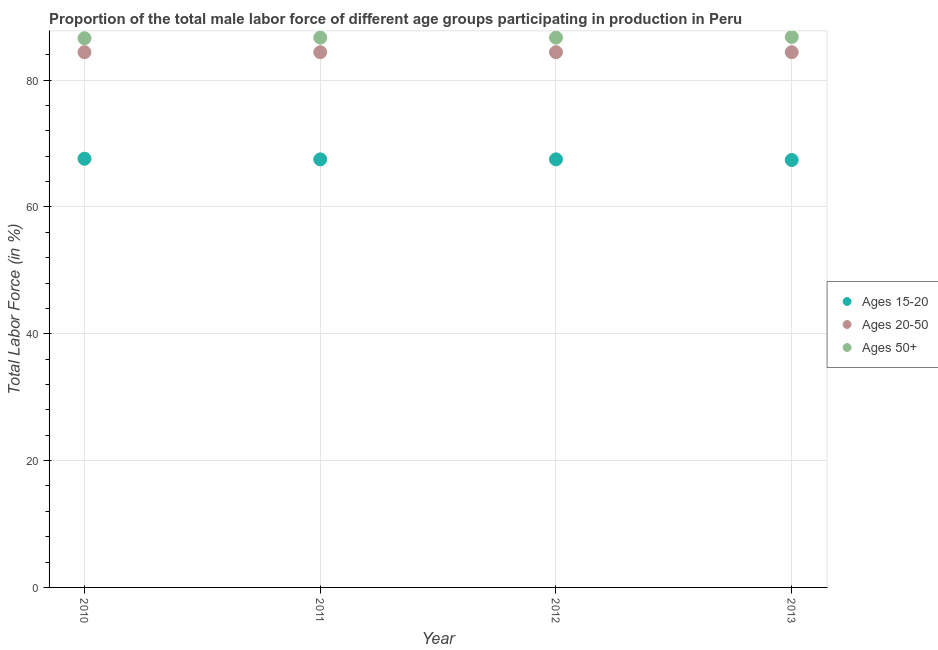Is the number of dotlines equal to the number of legend labels?
Keep it short and to the point. Yes. What is the percentage of male labor force above age 50 in 2012?
Your response must be concise. 86.7. Across all years, what is the maximum percentage of male labor force within the age group 20-50?
Provide a short and direct response. 84.4. Across all years, what is the minimum percentage of male labor force within the age group 20-50?
Keep it short and to the point. 84.4. In which year was the percentage of male labor force within the age group 20-50 minimum?
Give a very brief answer. 2010. What is the total percentage of male labor force within the age group 20-50 in the graph?
Your response must be concise. 337.6. What is the difference between the percentage of male labor force within the age group 20-50 in 2010 and that in 2012?
Offer a terse response. 0. What is the difference between the percentage of male labor force above age 50 in 2011 and the percentage of male labor force within the age group 15-20 in 2012?
Your response must be concise. 19.2. What is the average percentage of male labor force within the age group 15-20 per year?
Your response must be concise. 67.5. In the year 2011, what is the difference between the percentage of male labor force within the age group 15-20 and percentage of male labor force within the age group 20-50?
Your answer should be very brief. -16.9. What is the ratio of the percentage of male labor force above age 50 in 2011 to that in 2013?
Offer a terse response. 1. What is the difference between the highest and the second highest percentage of male labor force within the age group 15-20?
Make the answer very short. 0.1. What is the difference between the highest and the lowest percentage of male labor force above age 50?
Make the answer very short. 0.2. Is it the case that in every year, the sum of the percentage of male labor force within the age group 15-20 and percentage of male labor force within the age group 20-50 is greater than the percentage of male labor force above age 50?
Give a very brief answer. Yes. Does the percentage of male labor force within the age group 15-20 monotonically increase over the years?
Your answer should be very brief. No. Is the percentage of male labor force within the age group 15-20 strictly greater than the percentage of male labor force above age 50 over the years?
Provide a short and direct response. No. How many dotlines are there?
Offer a terse response. 3. How many years are there in the graph?
Keep it short and to the point. 4. Are the values on the major ticks of Y-axis written in scientific E-notation?
Ensure brevity in your answer.  No. Does the graph contain any zero values?
Ensure brevity in your answer.  No. How are the legend labels stacked?
Your response must be concise. Vertical. What is the title of the graph?
Your response must be concise. Proportion of the total male labor force of different age groups participating in production in Peru. Does "Slovak Republic" appear as one of the legend labels in the graph?
Give a very brief answer. No. What is the label or title of the Y-axis?
Give a very brief answer. Total Labor Force (in %). What is the Total Labor Force (in %) of Ages 15-20 in 2010?
Your answer should be very brief. 67.6. What is the Total Labor Force (in %) in Ages 20-50 in 2010?
Ensure brevity in your answer.  84.4. What is the Total Labor Force (in %) in Ages 50+ in 2010?
Your response must be concise. 86.6. What is the Total Labor Force (in %) of Ages 15-20 in 2011?
Offer a terse response. 67.5. What is the Total Labor Force (in %) in Ages 20-50 in 2011?
Ensure brevity in your answer.  84.4. What is the Total Labor Force (in %) in Ages 50+ in 2011?
Offer a very short reply. 86.7. What is the Total Labor Force (in %) in Ages 15-20 in 2012?
Give a very brief answer. 67.5. What is the Total Labor Force (in %) in Ages 20-50 in 2012?
Provide a succinct answer. 84.4. What is the Total Labor Force (in %) of Ages 50+ in 2012?
Make the answer very short. 86.7. What is the Total Labor Force (in %) of Ages 15-20 in 2013?
Ensure brevity in your answer.  67.4. What is the Total Labor Force (in %) of Ages 20-50 in 2013?
Give a very brief answer. 84.4. What is the Total Labor Force (in %) of Ages 50+ in 2013?
Give a very brief answer. 86.8. Across all years, what is the maximum Total Labor Force (in %) of Ages 15-20?
Offer a very short reply. 67.6. Across all years, what is the maximum Total Labor Force (in %) in Ages 20-50?
Offer a very short reply. 84.4. Across all years, what is the maximum Total Labor Force (in %) in Ages 50+?
Keep it short and to the point. 86.8. Across all years, what is the minimum Total Labor Force (in %) in Ages 15-20?
Offer a terse response. 67.4. Across all years, what is the minimum Total Labor Force (in %) in Ages 20-50?
Provide a short and direct response. 84.4. Across all years, what is the minimum Total Labor Force (in %) in Ages 50+?
Your answer should be compact. 86.6. What is the total Total Labor Force (in %) in Ages 15-20 in the graph?
Offer a very short reply. 270. What is the total Total Labor Force (in %) of Ages 20-50 in the graph?
Ensure brevity in your answer.  337.6. What is the total Total Labor Force (in %) in Ages 50+ in the graph?
Provide a short and direct response. 346.8. What is the difference between the Total Labor Force (in %) in Ages 15-20 in 2010 and that in 2011?
Ensure brevity in your answer.  0.1. What is the difference between the Total Labor Force (in %) in Ages 50+ in 2010 and that in 2011?
Offer a terse response. -0.1. What is the difference between the Total Labor Force (in %) of Ages 15-20 in 2010 and that in 2012?
Provide a succinct answer. 0.1. What is the difference between the Total Labor Force (in %) of Ages 20-50 in 2010 and that in 2012?
Your response must be concise. 0. What is the difference between the Total Labor Force (in %) in Ages 15-20 in 2010 and that in 2013?
Provide a short and direct response. 0.2. What is the difference between the Total Labor Force (in %) in Ages 20-50 in 2010 and that in 2013?
Your answer should be very brief. 0. What is the difference between the Total Labor Force (in %) in Ages 15-20 in 2011 and that in 2012?
Keep it short and to the point. 0. What is the difference between the Total Labor Force (in %) in Ages 20-50 in 2011 and that in 2013?
Your response must be concise. 0. What is the difference between the Total Labor Force (in %) of Ages 50+ in 2011 and that in 2013?
Make the answer very short. -0.1. What is the difference between the Total Labor Force (in %) in Ages 15-20 in 2010 and the Total Labor Force (in %) in Ages 20-50 in 2011?
Offer a terse response. -16.8. What is the difference between the Total Labor Force (in %) of Ages 15-20 in 2010 and the Total Labor Force (in %) of Ages 50+ in 2011?
Your answer should be very brief. -19.1. What is the difference between the Total Labor Force (in %) of Ages 20-50 in 2010 and the Total Labor Force (in %) of Ages 50+ in 2011?
Keep it short and to the point. -2.3. What is the difference between the Total Labor Force (in %) of Ages 15-20 in 2010 and the Total Labor Force (in %) of Ages 20-50 in 2012?
Offer a very short reply. -16.8. What is the difference between the Total Labor Force (in %) of Ages 15-20 in 2010 and the Total Labor Force (in %) of Ages 50+ in 2012?
Provide a short and direct response. -19.1. What is the difference between the Total Labor Force (in %) of Ages 20-50 in 2010 and the Total Labor Force (in %) of Ages 50+ in 2012?
Offer a terse response. -2.3. What is the difference between the Total Labor Force (in %) of Ages 15-20 in 2010 and the Total Labor Force (in %) of Ages 20-50 in 2013?
Offer a terse response. -16.8. What is the difference between the Total Labor Force (in %) in Ages 15-20 in 2010 and the Total Labor Force (in %) in Ages 50+ in 2013?
Your response must be concise. -19.2. What is the difference between the Total Labor Force (in %) in Ages 15-20 in 2011 and the Total Labor Force (in %) in Ages 20-50 in 2012?
Offer a terse response. -16.9. What is the difference between the Total Labor Force (in %) of Ages 15-20 in 2011 and the Total Labor Force (in %) of Ages 50+ in 2012?
Offer a terse response. -19.2. What is the difference between the Total Labor Force (in %) of Ages 20-50 in 2011 and the Total Labor Force (in %) of Ages 50+ in 2012?
Your answer should be very brief. -2.3. What is the difference between the Total Labor Force (in %) in Ages 15-20 in 2011 and the Total Labor Force (in %) in Ages 20-50 in 2013?
Give a very brief answer. -16.9. What is the difference between the Total Labor Force (in %) of Ages 15-20 in 2011 and the Total Labor Force (in %) of Ages 50+ in 2013?
Keep it short and to the point. -19.3. What is the difference between the Total Labor Force (in %) in Ages 20-50 in 2011 and the Total Labor Force (in %) in Ages 50+ in 2013?
Offer a terse response. -2.4. What is the difference between the Total Labor Force (in %) of Ages 15-20 in 2012 and the Total Labor Force (in %) of Ages 20-50 in 2013?
Provide a succinct answer. -16.9. What is the difference between the Total Labor Force (in %) of Ages 15-20 in 2012 and the Total Labor Force (in %) of Ages 50+ in 2013?
Your answer should be compact. -19.3. What is the difference between the Total Labor Force (in %) of Ages 20-50 in 2012 and the Total Labor Force (in %) of Ages 50+ in 2013?
Your answer should be very brief. -2.4. What is the average Total Labor Force (in %) of Ages 15-20 per year?
Your response must be concise. 67.5. What is the average Total Labor Force (in %) in Ages 20-50 per year?
Offer a very short reply. 84.4. What is the average Total Labor Force (in %) in Ages 50+ per year?
Offer a terse response. 86.7. In the year 2010, what is the difference between the Total Labor Force (in %) in Ages 15-20 and Total Labor Force (in %) in Ages 20-50?
Provide a short and direct response. -16.8. In the year 2010, what is the difference between the Total Labor Force (in %) in Ages 15-20 and Total Labor Force (in %) in Ages 50+?
Ensure brevity in your answer.  -19. In the year 2010, what is the difference between the Total Labor Force (in %) in Ages 20-50 and Total Labor Force (in %) in Ages 50+?
Keep it short and to the point. -2.2. In the year 2011, what is the difference between the Total Labor Force (in %) of Ages 15-20 and Total Labor Force (in %) of Ages 20-50?
Make the answer very short. -16.9. In the year 2011, what is the difference between the Total Labor Force (in %) of Ages 15-20 and Total Labor Force (in %) of Ages 50+?
Give a very brief answer. -19.2. In the year 2012, what is the difference between the Total Labor Force (in %) of Ages 15-20 and Total Labor Force (in %) of Ages 20-50?
Provide a succinct answer. -16.9. In the year 2012, what is the difference between the Total Labor Force (in %) of Ages 15-20 and Total Labor Force (in %) of Ages 50+?
Provide a short and direct response. -19.2. In the year 2013, what is the difference between the Total Labor Force (in %) of Ages 15-20 and Total Labor Force (in %) of Ages 20-50?
Provide a succinct answer. -17. In the year 2013, what is the difference between the Total Labor Force (in %) in Ages 15-20 and Total Labor Force (in %) in Ages 50+?
Make the answer very short. -19.4. In the year 2013, what is the difference between the Total Labor Force (in %) in Ages 20-50 and Total Labor Force (in %) in Ages 50+?
Offer a terse response. -2.4. What is the ratio of the Total Labor Force (in %) in Ages 15-20 in 2010 to that in 2011?
Your response must be concise. 1. What is the ratio of the Total Labor Force (in %) in Ages 20-50 in 2010 to that in 2012?
Ensure brevity in your answer.  1. What is the ratio of the Total Labor Force (in %) of Ages 15-20 in 2010 to that in 2013?
Give a very brief answer. 1. What is the ratio of the Total Labor Force (in %) in Ages 15-20 in 2011 to that in 2012?
Offer a very short reply. 1. What is the ratio of the Total Labor Force (in %) in Ages 50+ in 2011 to that in 2012?
Your response must be concise. 1. What is the ratio of the Total Labor Force (in %) in Ages 20-50 in 2011 to that in 2013?
Provide a succinct answer. 1. What is the ratio of the Total Labor Force (in %) of Ages 50+ in 2011 to that in 2013?
Provide a succinct answer. 1. What is the ratio of the Total Labor Force (in %) in Ages 50+ in 2012 to that in 2013?
Your answer should be very brief. 1. What is the difference between the highest and the lowest Total Labor Force (in %) in Ages 15-20?
Your answer should be very brief. 0.2. What is the difference between the highest and the lowest Total Labor Force (in %) in Ages 50+?
Give a very brief answer. 0.2. 